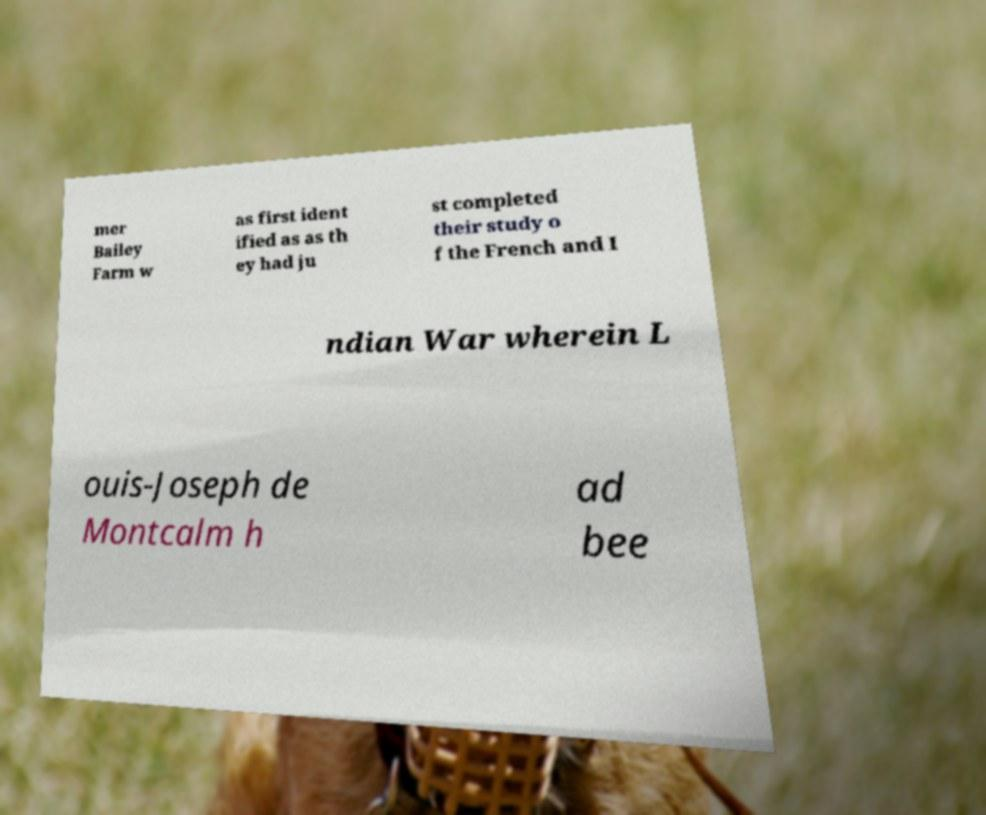Can you read and provide the text displayed in the image?This photo seems to have some interesting text. Can you extract and type it out for me? mer Bailey Farm w as first ident ified as as th ey had ju st completed their study o f the French and I ndian War wherein L ouis-Joseph de Montcalm h ad bee 